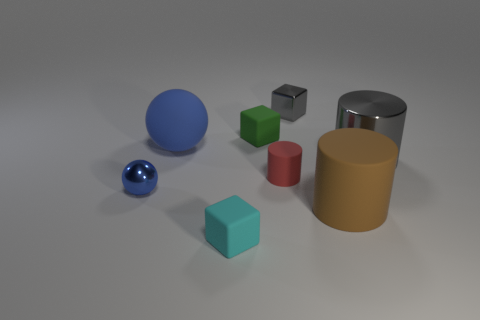The other blue metallic object that is the same shape as the large blue thing is what size?
Make the answer very short. Small. There is a gray thing to the right of the large brown thing; are there any rubber balls that are to the right of it?
Your response must be concise. No. Do the big rubber ball and the tiny ball have the same color?
Your answer should be compact. Yes. How many other things are the same shape as the blue metal object?
Your answer should be compact. 1. Is the number of big blue balls that are in front of the tiny cyan block greater than the number of small cyan matte blocks right of the shiny ball?
Your answer should be compact. No. There is a shiny thing left of the cyan thing; does it have the same size as the cylinder that is in front of the small red cylinder?
Ensure brevity in your answer.  No. What is the shape of the blue metal object?
Your response must be concise. Sphere. The rubber thing that is the same color as the tiny ball is what size?
Make the answer very short. Large. There is a big cylinder that is made of the same material as the small gray block; what is its color?
Offer a terse response. Gray. Is the tiny cyan object made of the same material as the blue sphere that is behind the tiny red cylinder?
Your answer should be very brief. Yes. 